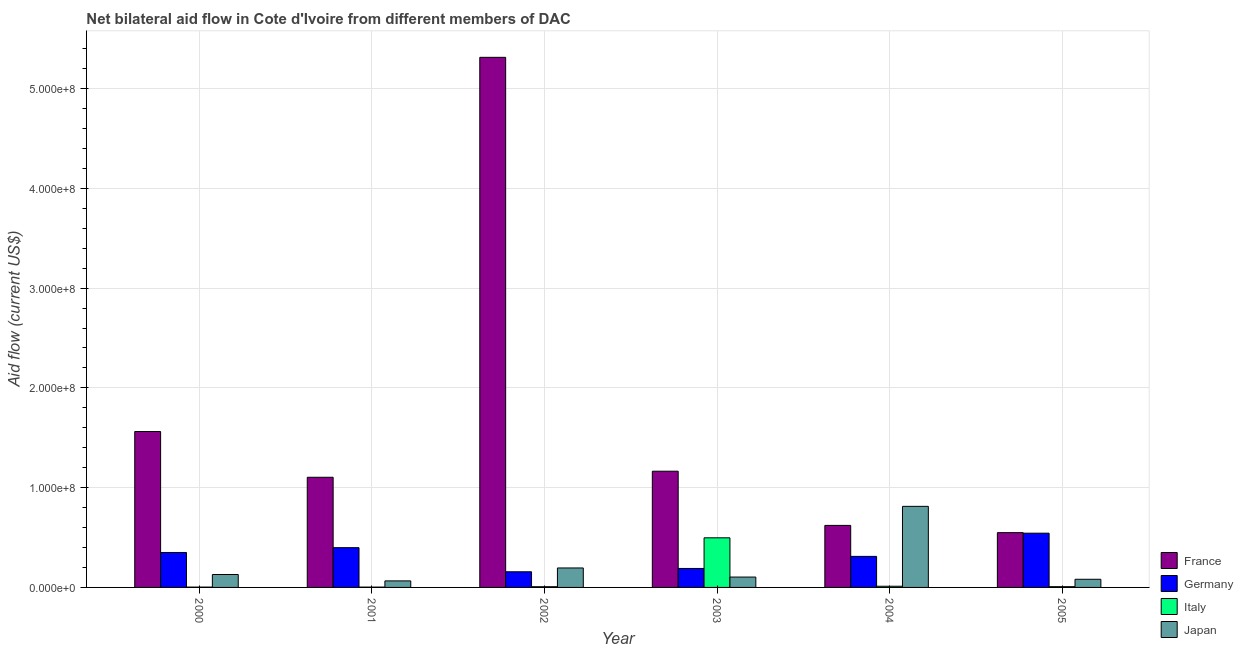How many different coloured bars are there?
Keep it short and to the point. 4. Are the number of bars on each tick of the X-axis equal?
Offer a terse response. Yes. What is the amount of aid given by germany in 2002?
Offer a very short reply. 1.57e+07. Across all years, what is the maximum amount of aid given by italy?
Ensure brevity in your answer.  4.97e+07. Across all years, what is the minimum amount of aid given by germany?
Offer a very short reply. 1.57e+07. In which year was the amount of aid given by germany maximum?
Offer a very short reply. 2005. What is the total amount of aid given by france in the graph?
Provide a succinct answer. 1.03e+09. What is the difference between the amount of aid given by japan in 2001 and that in 2005?
Offer a very short reply. -1.63e+06. What is the difference between the amount of aid given by japan in 2002 and the amount of aid given by germany in 2000?
Provide a succinct answer. 6.56e+06. What is the average amount of aid given by germany per year?
Keep it short and to the point. 3.25e+07. In the year 2001, what is the difference between the amount of aid given by france and amount of aid given by germany?
Offer a very short reply. 0. What is the ratio of the amount of aid given by japan in 2002 to that in 2004?
Ensure brevity in your answer.  0.24. Is the difference between the amount of aid given by japan in 2004 and 2005 greater than the difference between the amount of aid given by italy in 2004 and 2005?
Provide a succinct answer. No. What is the difference between the highest and the second highest amount of aid given by france?
Ensure brevity in your answer.  3.75e+08. What is the difference between the highest and the lowest amount of aid given by france?
Ensure brevity in your answer.  4.76e+08. Is the sum of the amount of aid given by germany in 2003 and 2004 greater than the maximum amount of aid given by japan across all years?
Provide a short and direct response. No. Is it the case that in every year, the sum of the amount of aid given by germany and amount of aid given by france is greater than the sum of amount of aid given by italy and amount of aid given by japan?
Your response must be concise. No. What does the 1st bar from the left in 2004 represents?
Provide a short and direct response. France. What does the 3rd bar from the right in 2002 represents?
Your answer should be compact. Germany. Is it the case that in every year, the sum of the amount of aid given by france and amount of aid given by germany is greater than the amount of aid given by italy?
Provide a short and direct response. Yes. How many bars are there?
Provide a succinct answer. 24. How many years are there in the graph?
Give a very brief answer. 6. Are the values on the major ticks of Y-axis written in scientific E-notation?
Give a very brief answer. Yes. Does the graph contain any zero values?
Your answer should be very brief. No. Where does the legend appear in the graph?
Your response must be concise. Bottom right. What is the title of the graph?
Make the answer very short. Net bilateral aid flow in Cote d'Ivoire from different members of DAC. What is the label or title of the Y-axis?
Your answer should be very brief. Aid flow (current US$). What is the Aid flow (current US$) in France in 2000?
Ensure brevity in your answer.  1.56e+08. What is the Aid flow (current US$) of Germany in 2000?
Offer a very short reply. 3.50e+07. What is the Aid flow (current US$) in Italy in 2000?
Your answer should be compact. 3.20e+05. What is the Aid flow (current US$) of Japan in 2000?
Make the answer very short. 1.30e+07. What is the Aid flow (current US$) in France in 2001?
Give a very brief answer. 1.10e+08. What is the Aid flow (current US$) of Germany in 2001?
Offer a terse response. 3.98e+07. What is the Aid flow (current US$) of Italy in 2001?
Give a very brief answer. 3.20e+05. What is the Aid flow (current US$) of Japan in 2001?
Give a very brief answer. 6.54e+06. What is the Aid flow (current US$) of France in 2002?
Your response must be concise. 5.31e+08. What is the Aid flow (current US$) of Germany in 2002?
Ensure brevity in your answer.  1.57e+07. What is the Aid flow (current US$) in Italy in 2002?
Ensure brevity in your answer.  7.10e+05. What is the Aid flow (current US$) of Japan in 2002?
Offer a very short reply. 1.95e+07. What is the Aid flow (current US$) of France in 2003?
Keep it short and to the point. 1.16e+08. What is the Aid flow (current US$) in Germany in 2003?
Your answer should be compact. 1.90e+07. What is the Aid flow (current US$) of Italy in 2003?
Offer a terse response. 4.97e+07. What is the Aid flow (current US$) in Japan in 2003?
Your response must be concise. 1.04e+07. What is the Aid flow (current US$) of France in 2004?
Offer a very short reply. 6.22e+07. What is the Aid flow (current US$) in Germany in 2004?
Provide a short and direct response. 3.11e+07. What is the Aid flow (current US$) of Italy in 2004?
Offer a terse response. 1.18e+06. What is the Aid flow (current US$) of Japan in 2004?
Your answer should be very brief. 8.13e+07. What is the Aid flow (current US$) of France in 2005?
Offer a terse response. 5.49e+07. What is the Aid flow (current US$) of Germany in 2005?
Keep it short and to the point. 5.44e+07. What is the Aid flow (current US$) of Italy in 2005?
Your answer should be compact. 7.60e+05. What is the Aid flow (current US$) of Japan in 2005?
Provide a succinct answer. 8.17e+06. Across all years, what is the maximum Aid flow (current US$) of France?
Offer a very short reply. 5.31e+08. Across all years, what is the maximum Aid flow (current US$) in Germany?
Provide a succinct answer. 5.44e+07. Across all years, what is the maximum Aid flow (current US$) in Italy?
Provide a succinct answer. 4.97e+07. Across all years, what is the maximum Aid flow (current US$) of Japan?
Your answer should be very brief. 8.13e+07. Across all years, what is the minimum Aid flow (current US$) of France?
Offer a terse response. 5.49e+07. Across all years, what is the minimum Aid flow (current US$) in Germany?
Your response must be concise. 1.57e+07. Across all years, what is the minimum Aid flow (current US$) of Japan?
Your response must be concise. 6.54e+06. What is the total Aid flow (current US$) of France in the graph?
Offer a terse response. 1.03e+09. What is the total Aid flow (current US$) in Germany in the graph?
Offer a terse response. 1.95e+08. What is the total Aid flow (current US$) in Italy in the graph?
Make the answer very short. 5.30e+07. What is the total Aid flow (current US$) of Japan in the graph?
Your answer should be very brief. 1.39e+08. What is the difference between the Aid flow (current US$) of France in 2000 and that in 2001?
Keep it short and to the point. 4.59e+07. What is the difference between the Aid flow (current US$) in Germany in 2000 and that in 2001?
Your answer should be compact. -4.82e+06. What is the difference between the Aid flow (current US$) in Japan in 2000 and that in 2001?
Your answer should be very brief. 6.41e+06. What is the difference between the Aid flow (current US$) of France in 2000 and that in 2002?
Keep it short and to the point. -3.75e+08. What is the difference between the Aid flow (current US$) in Germany in 2000 and that in 2002?
Your answer should be compact. 1.93e+07. What is the difference between the Aid flow (current US$) in Italy in 2000 and that in 2002?
Ensure brevity in your answer.  -3.90e+05. What is the difference between the Aid flow (current US$) of Japan in 2000 and that in 2002?
Provide a short and direct response. -6.56e+06. What is the difference between the Aid flow (current US$) of France in 2000 and that in 2003?
Your answer should be very brief. 3.98e+07. What is the difference between the Aid flow (current US$) in Germany in 2000 and that in 2003?
Offer a very short reply. 1.60e+07. What is the difference between the Aid flow (current US$) in Italy in 2000 and that in 2003?
Offer a very short reply. -4.94e+07. What is the difference between the Aid flow (current US$) in Japan in 2000 and that in 2003?
Offer a very short reply. 2.56e+06. What is the difference between the Aid flow (current US$) of France in 2000 and that in 2004?
Make the answer very short. 9.41e+07. What is the difference between the Aid flow (current US$) in Germany in 2000 and that in 2004?
Provide a succinct answer. 3.92e+06. What is the difference between the Aid flow (current US$) of Italy in 2000 and that in 2004?
Your answer should be very brief. -8.60e+05. What is the difference between the Aid flow (current US$) in Japan in 2000 and that in 2004?
Provide a short and direct response. -6.83e+07. What is the difference between the Aid flow (current US$) in France in 2000 and that in 2005?
Provide a short and direct response. 1.01e+08. What is the difference between the Aid flow (current US$) in Germany in 2000 and that in 2005?
Ensure brevity in your answer.  -1.93e+07. What is the difference between the Aid flow (current US$) in Italy in 2000 and that in 2005?
Offer a terse response. -4.40e+05. What is the difference between the Aid flow (current US$) of Japan in 2000 and that in 2005?
Provide a short and direct response. 4.78e+06. What is the difference between the Aid flow (current US$) of France in 2001 and that in 2002?
Give a very brief answer. -4.21e+08. What is the difference between the Aid flow (current US$) of Germany in 2001 and that in 2002?
Ensure brevity in your answer.  2.42e+07. What is the difference between the Aid flow (current US$) in Italy in 2001 and that in 2002?
Your response must be concise. -3.90e+05. What is the difference between the Aid flow (current US$) of Japan in 2001 and that in 2002?
Give a very brief answer. -1.30e+07. What is the difference between the Aid flow (current US$) in France in 2001 and that in 2003?
Give a very brief answer. -6.07e+06. What is the difference between the Aid flow (current US$) of Germany in 2001 and that in 2003?
Your answer should be very brief. 2.08e+07. What is the difference between the Aid flow (current US$) in Italy in 2001 and that in 2003?
Provide a succinct answer. -4.94e+07. What is the difference between the Aid flow (current US$) of Japan in 2001 and that in 2003?
Your answer should be very brief. -3.85e+06. What is the difference between the Aid flow (current US$) in France in 2001 and that in 2004?
Give a very brief answer. 4.82e+07. What is the difference between the Aid flow (current US$) of Germany in 2001 and that in 2004?
Keep it short and to the point. 8.74e+06. What is the difference between the Aid flow (current US$) in Italy in 2001 and that in 2004?
Ensure brevity in your answer.  -8.60e+05. What is the difference between the Aid flow (current US$) in Japan in 2001 and that in 2004?
Provide a succinct answer. -7.47e+07. What is the difference between the Aid flow (current US$) of France in 2001 and that in 2005?
Your response must be concise. 5.55e+07. What is the difference between the Aid flow (current US$) of Germany in 2001 and that in 2005?
Offer a very short reply. -1.45e+07. What is the difference between the Aid flow (current US$) in Italy in 2001 and that in 2005?
Your answer should be compact. -4.40e+05. What is the difference between the Aid flow (current US$) in Japan in 2001 and that in 2005?
Make the answer very short. -1.63e+06. What is the difference between the Aid flow (current US$) in France in 2002 and that in 2003?
Your answer should be compact. 4.15e+08. What is the difference between the Aid flow (current US$) in Germany in 2002 and that in 2003?
Your answer should be very brief. -3.32e+06. What is the difference between the Aid flow (current US$) in Italy in 2002 and that in 2003?
Ensure brevity in your answer.  -4.90e+07. What is the difference between the Aid flow (current US$) of Japan in 2002 and that in 2003?
Make the answer very short. 9.12e+06. What is the difference between the Aid flow (current US$) in France in 2002 and that in 2004?
Offer a terse response. 4.69e+08. What is the difference between the Aid flow (current US$) in Germany in 2002 and that in 2004?
Provide a short and direct response. -1.54e+07. What is the difference between the Aid flow (current US$) of Italy in 2002 and that in 2004?
Your answer should be compact. -4.70e+05. What is the difference between the Aid flow (current US$) in Japan in 2002 and that in 2004?
Your answer should be very brief. -6.18e+07. What is the difference between the Aid flow (current US$) in France in 2002 and that in 2005?
Your response must be concise. 4.76e+08. What is the difference between the Aid flow (current US$) of Germany in 2002 and that in 2005?
Your response must be concise. -3.87e+07. What is the difference between the Aid flow (current US$) of Italy in 2002 and that in 2005?
Offer a terse response. -5.00e+04. What is the difference between the Aid flow (current US$) in Japan in 2002 and that in 2005?
Provide a succinct answer. 1.13e+07. What is the difference between the Aid flow (current US$) in France in 2003 and that in 2004?
Make the answer very short. 5.43e+07. What is the difference between the Aid flow (current US$) in Germany in 2003 and that in 2004?
Offer a very short reply. -1.21e+07. What is the difference between the Aid flow (current US$) of Italy in 2003 and that in 2004?
Ensure brevity in your answer.  4.86e+07. What is the difference between the Aid flow (current US$) in Japan in 2003 and that in 2004?
Ensure brevity in your answer.  -7.09e+07. What is the difference between the Aid flow (current US$) of France in 2003 and that in 2005?
Provide a succinct answer. 6.16e+07. What is the difference between the Aid flow (current US$) in Germany in 2003 and that in 2005?
Provide a succinct answer. -3.54e+07. What is the difference between the Aid flow (current US$) in Italy in 2003 and that in 2005?
Provide a succinct answer. 4.90e+07. What is the difference between the Aid flow (current US$) of Japan in 2003 and that in 2005?
Give a very brief answer. 2.22e+06. What is the difference between the Aid flow (current US$) in France in 2004 and that in 2005?
Keep it short and to the point. 7.26e+06. What is the difference between the Aid flow (current US$) in Germany in 2004 and that in 2005?
Provide a short and direct response. -2.33e+07. What is the difference between the Aid flow (current US$) of Italy in 2004 and that in 2005?
Make the answer very short. 4.20e+05. What is the difference between the Aid flow (current US$) in Japan in 2004 and that in 2005?
Offer a very short reply. 7.31e+07. What is the difference between the Aid flow (current US$) in France in 2000 and the Aid flow (current US$) in Germany in 2001?
Provide a short and direct response. 1.16e+08. What is the difference between the Aid flow (current US$) of France in 2000 and the Aid flow (current US$) of Italy in 2001?
Give a very brief answer. 1.56e+08. What is the difference between the Aid flow (current US$) of France in 2000 and the Aid flow (current US$) of Japan in 2001?
Provide a short and direct response. 1.50e+08. What is the difference between the Aid flow (current US$) of Germany in 2000 and the Aid flow (current US$) of Italy in 2001?
Ensure brevity in your answer.  3.47e+07. What is the difference between the Aid flow (current US$) of Germany in 2000 and the Aid flow (current US$) of Japan in 2001?
Offer a very short reply. 2.85e+07. What is the difference between the Aid flow (current US$) of Italy in 2000 and the Aid flow (current US$) of Japan in 2001?
Offer a very short reply. -6.22e+06. What is the difference between the Aid flow (current US$) in France in 2000 and the Aid flow (current US$) in Germany in 2002?
Your answer should be compact. 1.41e+08. What is the difference between the Aid flow (current US$) in France in 2000 and the Aid flow (current US$) in Italy in 2002?
Provide a succinct answer. 1.56e+08. What is the difference between the Aid flow (current US$) in France in 2000 and the Aid flow (current US$) in Japan in 2002?
Provide a succinct answer. 1.37e+08. What is the difference between the Aid flow (current US$) in Germany in 2000 and the Aid flow (current US$) in Italy in 2002?
Make the answer very short. 3.43e+07. What is the difference between the Aid flow (current US$) in Germany in 2000 and the Aid flow (current US$) in Japan in 2002?
Your response must be concise. 1.55e+07. What is the difference between the Aid flow (current US$) of Italy in 2000 and the Aid flow (current US$) of Japan in 2002?
Give a very brief answer. -1.92e+07. What is the difference between the Aid flow (current US$) in France in 2000 and the Aid flow (current US$) in Germany in 2003?
Ensure brevity in your answer.  1.37e+08. What is the difference between the Aid flow (current US$) in France in 2000 and the Aid flow (current US$) in Italy in 2003?
Offer a very short reply. 1.07e+08. What is the difference between the Aid flow (current US$) of France in 2000 and the Aid flow (current US$) of Japan in 2003?
Offer a very short reply. 1.46e+08. What is the difference between the Aid flow (current US$) of Germany in 2000 and the Aid flow (current US$) of Italy in 2003?
Offer a very short reply. -1.47e+07. What is the difference between the Aid flow (current US$) of Germany in 2000 and the Aid flow (current US$) of Japan in 2003?
Make the answer very short. 2.46e+07. What is the difference between the Aid flow (current US$) in Italy in 2000 and the Aid flow (current US$) in Japan in 2003?
Make the answer very short. -1.01e+07. What is the difference between the Aid flow (current US$) in France in 2000 and the Aid flow (current US$) in Germany in 2004?
Your answer should be compact. 1.25e+08. What is the difference between the Aid flow (current US$) in France in 2000 and the Aid flow (current US$) in Italy in 2004?
Your response must be concise. 1.55e+08. What is the difference between the Aid flow (current US$) in France in 2000 and the Aid flow (current US$) in Japan in 2004?
Your answer should be very brief. 7.50e+07. What is the difference between the Aid flow (current US$) of Germany in 2000 and the Aid flow (current US$) of Italy in 2004?
Provide a succinct answer. 3.38e+07. What is the difference between the Aid flow (current US$) of Germany in 2000 and the Aid flow (current US$) of Japan in 2004?
Your answer should be very brief. -4.62e+07. What is the difference between the Aid flow (current US$) of Italy in 2000 and the Aid flow (current US$) of Japan in 2004?
Ensure brevity in your answer.  -8.09e+07. What is the difference between the Aid flow (current US$) in France in 2000 and the Aid flow (current US$) in Germany in 2005?
Offer a very short reply. 1.02e+08. What is the difference between the Aid flow (current US$) of France in 2000 and the Aid flow (current US$) of Italy in 2005?
Your answer should be compact. 1.56e+08. What is the difference between the Aid flow (current US$) of France in 2000 and the Aid flow (current US$) of Japan in 2005?
Your answer should be very brief. 1.48e+08. What is the difference between the Aid flow (current US$) of Germany in 2000 and the Aid flow (current US$) of Italy in 2005?
Your answer should be very brief. 3.43e+07. What is the difference between the Aid flow (current US$) of Germany in 2000 and the Aid flow (current US$) of Japan in 2005?
Provide a short and direct response. 2.69e+07. What is the difference between the Aid flow (current US$) in Italy in 2000 and the Aid flow (current US$) in Japan in 2005?
Your response must be concise. -7.85e+06. What is the difference between the Aid flow (current US$) in France in 2001 and the Aid flow (current US$) in Germany in 2002?
Your response must be concise. 9.47e+07. What is the difference between the Aid flow (current US$) in France in 2001 and the Aid flow (current US$) in Italy in 2002?
Your answer should be very brief. 1.10e+08. What is the difference between the Aid flow (current US$) in France in 2001 and the Aid flow (current US$) in Japan in 2002?
Ensure brevity in your answer.  9.09e+07. What is the difference between the Aid flow (current US$) of Germany in 2001 and the Aid flow (current US$) of Italy in 2002?
Ensure brevity in your answer.  3.91e+07. What is the difference between the Aid flow (current US$) in Germany in 2001 and the Aid flow (current US$) in Japan in 2002?
Keep it short and to the point. 2.03e+07. What is the difference between the Aid flow (current US$) in Italy in 2001 and the Aid flow (current US$) in Japan in 2002?
Offer a terse response. -1.92e+07. What is the difference between the Aid flow (current US$) in France in 2001 and the Aid flow (current US$) in Germany in 2003?
Your response must be concise. 9.14e+07. What is the difference between the Aid flow (current US$) in France in 2001 and the Aid flow (current US$) in Italy in 2003?
Your answer should be compact. 6.07e+07. What is the difference between the Aid flow (current US$) of France in 2001 and the Aid flow (current US$) of Japan in 2003?
Your answer should be compact. 1.00e+08. What is the difference between the Aid flow (current US$) of Germany in 2001 and the Aid flow (current US$) of Italy in 2003?
Make the answer very short. -9.88e+06. What is the difference between the Aid flow (current US$) of Germany in 2001 and the Aid flow (current US$) of Japan in 2003?
Offer a very short reply. 2.95e+07. What is the difference between the Aid flow (current US$) in Italy in 2001 and the Aid flow (current US$) in Japan in 2003?
Your answer should be very brief. -1.01e+07. What is the difference between the Aid flow (current US$) of France in 2001 and the Aid flow (current US$) of Germany in 2004?
Ensure brevity in your answer.  7.93e+07. What is the difference between the Aid flow (current US$) of France in 2001 and the Aid flow (current US$) of Italy in 2004?
Give a very brief answer. 1.09e+08. What is the difference between the Aid flow (current US$) in France in 2001 and the Aid flow (current US$) in Japan in 2004?
Offer a very short reply. 2.91e+07. What is the difference between the Aid flow (current US$) of Germany in 2001 and the Aid flow (current US$) of Italy in 2004?
Your response must be concise. 3.87e+07. What is the difference between the Aid flow (current US$) of Germany in 2001 and the Aid flow (current US$) of Japan in 2004?
Offer a very short reply. -4.14e+07. What is the difference between the Aid flow (current US$) of Italy in 2001 and the Aid flow (current US$) of Japan in 2004?
Keep it short and to the point. -8.09e+07. What is the difference between the Aid flow (current US$) of France in 2001 and the Aid flow (current US$) of Germany in 2005?
Your answer should be compact. 5.60e+07. What is the difference between the Aid flow (current US$) in France in 2001 and the Aid flow (current US$) in Italy in 2005?
Provide a succinct answer. 1.10e+08. What is the difference between the Aid flow (current US$) of France in 2001 and the Aid flow (current US$) of Japan in 2005?
Provide a short and direct response. 1.02e+08. What is the difference between the Aid flow (current US$) in Germany in 2001 and the Aid flow (current US$) in Italy in 2005?
Your answer should be very brief. 3.91e+07. What is the difference between the Aid flow (current US$) of Germany in 2001 and the Aid flow (current US$) of Japan in 2005?
Give a very brief answer. 3.17e+07. What is the difference between the Aid flow (current US$) of Italy in 2001 and the Aid flow (current US$) of Japan in 2005?
Give a very brief answer. -7.85e+06. What is the difference between the Aid flow (current US$) in France in 2002 and the Aid flow (current US$) in Germany in 2003?
Ensure brevity in your answer.  5.12e+08. What is the difference between the Aid flow (current US$) of France in 2002 and the Aid flow (current US$) of Italy in 2003?
Offer a terse response. 4.82e+08. What is the difference between the Aid flow (current US$) of France in 2002 and the Aid flow (current US$) of Japan in 2003?
Keep it short and to the point. 5.21e+08. What is the difference between the Aid flow (current US$) in Germany in 2002 and the Aid flow (current US$) in Italy in 2003?
Your answer should be very brief. -3.40e+07. What is the difference between the Aid flow (current US$) in Germany in 2002 and the Aid flow (current US$) in Japan in 2003?
Ensure brevity in your answer.  5.30e+06. What is the difference between the Aid flow (current US$) in Italy in 2002 and the Aid flow (current US$) in Japan in 2003?
Keep it short and to the point. -9.68e+06. What is the difference between the Aid flow (current US$) of France in 2002 and the Aid flow (current US$) of Germany in 2004?
Offer a terse response. 5.00e+08. What is the difference between the Aid flow (current US$) in France in 2002 and the Aid flow (current US$) in Italy in 2004?
Make the answer very short. 5.30e+08. What is the difference between the Aid flow (current US$) of France in 2002 and the Aid flow (current US$) of Japan in 2004?
Your response must be concise. 4.50e+08. What is the difference between the Aid flow (current US$) of Germany in 2002 and the Aid flow (current US$) of Italy in 2004?
Give a very brief answer. 1.45e+07. What is the difference between the Aid flow (current US$) of Germany in 2002 and the Aid flow (current US$) of Japan in 2004?
Ensure brevity in your answer.  -6.56e+07. What is the difference between the Aid flow (current US$) in Italy in 2002 and the Aid flow (current US$) in Japan in 2004?
Offer a very short reply. -8.06e+07. What is the difference between the Aid flow (current US$) of France in 2002 and the Aid flow (current US$) of Germany in 2005?
Keep it short and to the point. 4.77e+08. What is the difference between the Aid flow (current US$) in France in 2002 and the Aid flow (current US$) in Italy in 2005?
Provide a succinct answer. 5.31e+08. What is the difference between the Aid flow (current US$) in France in 2002 and the Aid flow (current US$) in Japan in 2005?
Your answer should be very brief. 5.23e+08. What is the difference between the Aid flow (current US$) in Germany in 2002 and the Aid flow (current US$) in Italy in 2005?
Make the answer very short. 1.49e+07. What is the difference between the Aid flow (current US$) in Germany in 2002 and the Aid flow (current US$) in Japan in 2005?
Your answer should be very brief. 7.52e+06. What is the difference between the Aid flow (current US$) in Italy in 2002 and the Aid flow (current US$) in Japan in 2005?
Offer a terse response. -7.46e+06. What is the difference between the Aid flow (current US$) of France in 2003 and the Aid flow (current US$) of Germany in 2004?
Make the answer very short. 8.54e+07. What is the difference between the Aid flow (current US$) in France in 2003 and the Aid flow (current US$) in Italy in 2004?
Give a very brief answer. 1.15e+08. What is the difference between the Aid flow (current US$) of France in 2003 and the Aid flow (current US$) of Japan in 2004?
Offer a terse response. 3.52e+07. What is the difference between the Aid flow (current US$) of Germany in 2003 and the Aid flow (current US$) of Italy in 2004?
Provide a short and direct response. 1.78e+07. What is the difference between the Aid flow (current US$) in Germany in 2003 and the Aid flow (current US$) in Japan in 2004?
Keep it short and to the point. -6.22e+07. What is the difference between the Aid flow (current US$) of Italy in 2003 and the Aid flow (current US$) of Japan in 2004?
Your response must be concise. -3.15e+07. What is the difference between the Aid flow (current US$) of France in 2003 and the Aid flow (current US$) of Germany in 2005?
Offer a terse response. 6.21e+07. What is the difference between the Aid flow (current US$) of France in 2003 and the Aid flow (current US$) of Italy in 2005?
Provide a succinct answer. 1.16e+08. What is the difference between the Aid flow (current US$) of France in 2003 and the Aid flow (current US$) of Japan in 2005?
Your answer should be compact. 1.08e+08. What is the difference between the Aid flow (current US$) in Germany in 2003 and the Aid flow (current US$) in Italy in 2005?
Provide a succinct answer. 1.82e+07. What is the difference between the Aid flow (current US$) in Germany in 2003 and the Aid flow (current US$) in Japan in 2005?
Keep it short and to the point. 1.08e+07. What is the difference between the Aid flow (current US$) in Italy in 2003 and the Aid flow (current US$) in Japan in 2005?
Make the answer very short. 4.16e+07. What is the difference between the Aid flow (current US$) in France in 2004 and the Aid flow (current US$) in Germany in 2005?
Your answer should be compact. 7.79e+06. What is the difference between the Aid flow (current US$) of France in 2004 and the Aid flow (current US$) of Italy in 2005?
Make the answer very short. 6.14e+07. What is the difference between the Aid flow (current US$) in France in 2004 and the Aid flow (current US$) in Japan in 2005?
Ensure brevity in your answer.  5.40e+07. What is the difference between the Aid flow (current US$) of Germany in 2004 and the Aid flow (current US$) of Italy in 2005?
Your answer should be very brief. 3.04e+07. What is the difference between the Aid flow (current US$) in Germany in 2004 and the Aid flow (current US$) in Japan in 2005?
Make the answer very short. 2.29e+07. What is the difference between the Aid flow (current US$) of Italy in 2004 and the Aid flow (current US$) of Japan in 2005?
Your response must be concise. -6.99e+06. What is the average Aid flow (current US$) in France per year?
Ensure brevity in your answer.  1.72e+08. What is the average Aid flow (current US$) in Germany per year?
Provide a short and direct response. 3.25e+07. What is the average Aid flow (current US$) of Italy per year?
Provide a succinct answer. 8.84e+06. What is the average Aid flow (current US$) in Japan per year?
Ensure brevity in your answer.  2.31e+07. In the year 2000, what is the difference between the Aid flow (current US$) of France and Aid flow (current US$) of Germany?
Offer a very short reply. 1.21e+08. In the year 2000, what is the difference between the Aid flow (current US$) of France and Aid flow (current US$) of Italy?
Give a very brief answer. 1.56e+08. In the year 2000, what is the difference between the Aid flow (current US$) in France and Aid flow (current US$) in Japan?
Keep it short and to the point. 1.43e+08. In the year 2000, what is the difference between the Aid flow (current US$) in Germany and Aid flow (current US$) in Italy?
Keep it short and to the point. 3.47e+07. In the year 2000, what is the difference between the Aid flow (current US$) of Germany and Aid flow (current US$) of Japan?
Your answer should be compact. 2.21e+07. In the year 2000, what is the difference between the Aid flow (current US$) in Italy and Aid flow (current US$) in Japan?
Your response must be concise. -1.26e+07. In the year 2001, what is the difference between the Aid flow (current US$) in France and Aid flow (current US$) in Germany?
Make the answer very short. 7.06e+07. In the year 2001, what is the difference between the Aid flow (current US$) of France and Aid flow (current US$) of Italy?
Provide a succinct answer. 1.10e+08. In the year 2001, what is the difference between the Aid flow (current US$) of France and Aid flow (current US$) of Japan?
Your response must be concise. 1.04e+08. In the year 2001, what is the difference between the Aid flow (current US$) of Germany and Aid flow (current US$) of Italy?
Ensure brevity in your answer.  3.95e+07. In the year 2001, what is the difference between the Aid flow (current US$) of Germany and Aid flow (current US$) of Japan?
Your answer should be compact. 3.33e+07. In the year 2001, what is the difference between the Aid flow (current US$) in Italy and Aid flow (current US$) in Japan?
Offer a very short reply. -6.22e+06. In the year 2002, what is the difference between the Aid flow (current US$) of France and Aid flow (current US$) of Germany?
Your answer should be compact. 5.16e+08. In the year 2002, what is the difference between the Aid flow (current US$) in France and Aid flow (current US$) in Italy?
Your answer should be very brief. 5.31e+08. In the year 2002, what is the difference between the Aid flow (current US$) in France and Aid flow (current US$) in Japan?
Your answer should be compact. 5.12e+08. In the year 2002, what is the difference between the Aid flow (current US$) of Germany and Aid flow (current US$) of Italy?
Your answer should be very brief. 1.50e+07. In the year 2002, what is the difference between the Aid flow (current US$) of Germany and Aid flow (current US$) of Japan?
Your answer should be very brief. -3.82e+06. In the year 2002, what is the difference between the Aid flow (current US$) in Italy and Aid flow (current US$) in Japan?
Provide a short and direct response. -1.88e+07. In the year 2003, what is the difference between the Aid flow (current US$) of France and Aid flow (current US$) of Germany?
Your answer should be compact. 9.75e+07. In the year 2003, what is the difference between the Aid flow (current US$) in France and Aid flow (current US$) in Italy?
Your answer should be very brief. 6.67e+07. In the year 2003, what is the difference between the Aid flow (current US$) in France and Aid flow (current US$) in Japan?
Offer a terse response. 1.06e+08. In the year 2003, what is the difference between the Aid flow (current US$) in Germany and Aid flow (current US$) in Italy?
Provide a succinct answer. -3.07e+07. In the year 2003, what is the difference between the Aid flow (current US$) in Germany and Aid flow (current US$) in Japan?
Give a very brief answer. 8.62e+06. In the year 2003, what is the difference between the Aid flow (current US$) of Italy and Aid flow (current US$) of Japan?
Give a very brief answer. 3.93e+07. In the year 2004, what is the difference between the Aid flow (current US$) of France and Aid flow (current US$) of Germany?
Keep it short and to the point. 3.10e+07. In the year 2004, what is the difference between the Aid flow (current US$) in France and Aid flow (current US$) in Italy?
Your answer should be very brief. 6.10e+07. In the year 2004, what is the difference between the Aid flow (current US$) in France and Aid flow (current US$) in Japan?
Provide a succinct answer. -1.91e+07. In the year 2004, what is the difference between the Aid flow (current US$) of Germany and Aid flow (current US$) of Italy?
Keep it short and to the point. 2.99e+07. In the year 2004, what is the difference between the Aid flow (current US$) of Germany and Aid flow (current US$) of Japan?
Offer a very short reply. -5.02e+07. In the year 2004, what is the difference between the Aid flow (current US$) of Italy and Aid flow (current US$) of Japan?
Provide a succinct answer. -8.01e+07. In the year 2005, what is the difference between the Aid flow (current US$) of France and Aid flow (current US$) of Germany?
Provide a short and direct response. 5.30e+05. In the year 2005, what is the difference between the Aid flow (current US$) of France and Aid flow (current US$) of Italy?
Offer a terse response. 5.41e+07. In the year 2005, what is the difference between the Aid flow (current US$) in France and Aid flow (current US$) in Japan?
Your answer should be very brief. 4.67e+07. In the year 2005, what is the difference between the Aid flow (current US$) of Germany and Aid flow (current US$) of Italy?
Your answer should be compact. 5.36e+07. In the year 2005, what is the difference between the Aid flow (current US$) in Germany and Aid flow (current US$) in Japan?
Your response must be concise. 4.62e+07. In the year 2005, what is the difference between the Aid flow (current US$) in Italy and Aid flow (current US$) in Japan?
Give a very brief answer. -7.41e+06. What is the ratio of the Aid flow (current US$) of France in 2000 to that in 2001?
Keep it short and to the point. 1.42. What is the ratio of the Aid flow (current US$) in Germany in 2000 to that in 2001?
Your response must be concise. 0.88. What is the ratio of the Aid flow (current US$) of Italy in 2000 to that in 2001?
Offer a very short reply. 1. What is the ratio of the Aid flow (current US$) in Japan in 2000 to that in 2001?
Your answer should be compact. 1.98. What is the ratio of the Aid flow (current US$) in France in 2000 to that in 2002?
Provide a succinct answer. 0.29. What is the ratio of the Aid flow (current US$) of Germany in 2000 to that in 2002?
Ensure brevity in your answer.  2.23. What is the ratio of the Aid flow (current US$) in Italy in 2000 to that in 2002?
Offer a very short reply. 0.45. What is the ratio of the Aid flow (current US$) in Japan in 2000 to that in 2002?
Your answer should be compact. 0.66. What is the ratio of the Aid flow (current US$) in France in 2000 to that in 2003?
Offer a very short reply. 1.34. What is the ratio of the Aid flow (current US$) in Germany in 2000 to that in 2003?
Give a very brief answer. 1.84. What is the ratio of the Aid flow (current US$) in Italy in 2000 to that in 2003?
Provide a succinct answer. 0.01. What is the ratio of the Aid flow (current US$) in Japan in 2000 to that in 2003?
Give a very brief answer. 1.25. What is the ratio of the Aid flow (current US$) in France in 2000 to that in 2004?
Offer a very short reply. 2.51. What is the ratio of the Aid flow (current US$) in Germany in 2000 to that in 2004?
Your answer should be very brief. 1.13. What is the ratio of the Aid flow (current US$) of Italy in 2000 to that in 2004?
Offer a very short reply. 0.27. What is the ratio of the Aid flow (current US$) in Japan in 2000 to that in 2004?
Offer a very short reply. 0.16. What is the ratio of the Aid flow (current US$) of France in 2000 to that in 2005?
Your answer should be very brief. 2.85. What is the ratio of the Aid flow (current US$) in Germany in 2000 to that in 2005?
Keep it short and to the point. 0.64. What is the ratio of the Aid flow (current US$) of Italy in 2000 to that in 2005?
Provide a succinct answer. 0.42. What is the ratio of the Aid flow (current US$) of Japan in 2000 to that in 2005?
Your response must be concise. 1.59. What is the ratio of the Aid flow (current US$) in France in 2001 to that in 2002?
Provide a succinct answer. 0.21. What is the ratio of the Aid flow (current US$) in Germany in 2001 to that in 2002?
Keep it short and to the point. 2.54. What is the ratio of the Aid flow (current US$) in Italy in 2001 to that in 2002?
Keep it short and to the point. 0.45. What is the ratio of the Aid flow (current US$) in Japan in 2001 to that in 2002?
Offer a very short reply. 0.34. What is the ratio of the Aid flow (current US$) in France in 2001 to that in 2003?
Offer a very short reply. 0.95. What is the ratio of the Aid flow (current US$) of Germany in 2001 to that in 2003?
Your answer should be very brief. 2.1. What is the ratio of the Aid flow (current US$) in Italy in 2001 to that in 2003?
Your answer should be very brief. 0.01. What is the ratio of the Aid flow (current US$) of Japan in 2001 to that in 2003?
Provide a succinct answer. 0.63. What is the ratio of the Aid flow (current US$) of France in 2001 to that in 2004?
Provide a short and direct response. 1.78. What is the ratio of the Aid flow (current US$) of Germany in 2001 to that in 2004?
Your response must be concise. 1.28. What is the ratio of the Aid flow (current US$) in Italy in 2001 to that in 2004?
Make the answer very short. 0.27. What is the ratio of the Aid flow (current US$) of Japan in 2001 to that in 2004?
Provide a succinct answer. 0.08. What is the ratio of the Aid flow (current US$) of France in 2001 to that in 2005?
Your answer should be compact. 2.01. What is the ratio of the Aid flow (current US$) of Germany in 2001 to that in 2005?
Provide a short and direct response. 0.73. What is the ratio of the Aid flow (current US$) in Italy in 2001 to that in 2005?
Provide a short and direct response. 0.42. What is the ratio of the Aid flow (current US$) of Japan in 2001 to that in 2005?
Provide a succinct answer. 0.8. What is the ratio of the Aid flow (current US$) in France in 2002 to that in 2003?
Provide a succinct answer. 4.56. What is the ratio of the Aid flow (current US$) of Germany in 2002 to that in 2003?
Keep it short and to the point. 0.83. What is the ratio of the Aid flow (current US$) of Italy in 2002 to that in 2003?
Offer a very short reply. 0.01. What is the ratio of the Aid flow (current US$) in Japan in 2002 to that in 2003?
Keep it short and to the point. 1.88. What is the ratio of the Aid flow (current US$) of France in 2002 to that in 2004?
Make the answer very short. 8.55. What is the ratio of the Aid flow (current US$) in Germany in 2002 to that in 2004?
Keep it short and to the point. 0.5. What is the ratio of the Aid flow (current US$) in Italy in 2002 to that in 2004?
Offer a terse response. 0.6. What is the ratio of the Aid flow (current US$) of Japan in 2002 to that in 2004?
Provide a succinct answer. 0.24. What is the ratio of the Aid flow (current US$) of France in 2002 to that in 2005?
Make the answer very short. 9.68. What is the ratio of the Aid flow (current US$) in Germany in 2002 to that in 2005?
Ensure brevity in your answer.  0.29. What is the ratio of the Aid flow (current US$) in Italy in 2002 to that in 2005?
Offer a very short reply. 0.93. What is the ratio of the Aid flow (current US$) in Japan in 2002 to that in 2005?
Keep it short and to the point. 2.39. What is the ratio of the Aid flow (current US$) of France in 2003 to that in 2004?
Make the answer very short. 1.87. What is the ratio of the Aid flow (current US$) of Germany in 2003 to that in 2004?
Offer a terse response. 0.61. What is the ratio of the Aid flow (current US$) of Italy in 2003 to that in 2004?
Make the answer very short. 42.14. What is the ratio of the Aid flow (current US$) in Japan in 2003 to that in 2004?
Offer a very short reply. 0.13. What is the ratio of the Aid flow (current US$) in France in 2003 to that in 2005?
Make the answer very short. 2.12. What is the ratio of the Aid flow (current US$) in Germany in 2003 to that in 2005?
Offer a very short reply. 0.35. What is the ratio of the Aid flow (current US$) of Italy in 2003 to that in 2005?
Ensure brevity in your answer.  65.43. What is the ratio of the Aid flow (current US$) in Japan in 2003 to that in 2005?
Offer a very short reply. 1.27. What is the ratio of the Aid flow (current US$) in France in 2004 to that in 2005?
Offer a terse response. 1.13. What is the ratio of the Aid flow (current US$) in Germany in 2004 to that in 2005?
Provide a succinct answer. 0.57. What is the ratio of the Aid flow (current US$) in Italy in 2004 to that in 2005?
Make the answer very short. 1.55. What is the ratio of the Aid flow (current US$) in Japan in 2004 to that in 2005?
Your answer should be compact. 9.95. What is the difference between the highest and the second highest Aid flow (current US$) in France?
Keep it short and to the point. 3.75e+08. What is the difference between the highest and the second highest Aid flow (current US$) in Germany?
Make the answer very short. 1.45e+07. What is the difference between the highest and the second highest Aid flow (current US$) in Italy?
Offer a terse response. 4.86e+07. What is the difference between the highest and the second highest Aid flow (current US$) of Japan?
Offer a very short reply. 6.18e+07. What is the difference between the highest and the lowest Aid flow (current US$) in France?
Offer a very short reply. 4.76e+08. What is the difference between the highest and the lowest Aid flow (current US$) of Germany?
Provide a short and direct response. 3.87e+07. What is the difference between the highest and the lowest Aid flow (current US$) in Italy?
Your response must be concise. 4.94e+07. What is the difference between the highest and the lowest Aid flow (current US$) in Japan?
Your answer should be compact. 7.47e+07. 